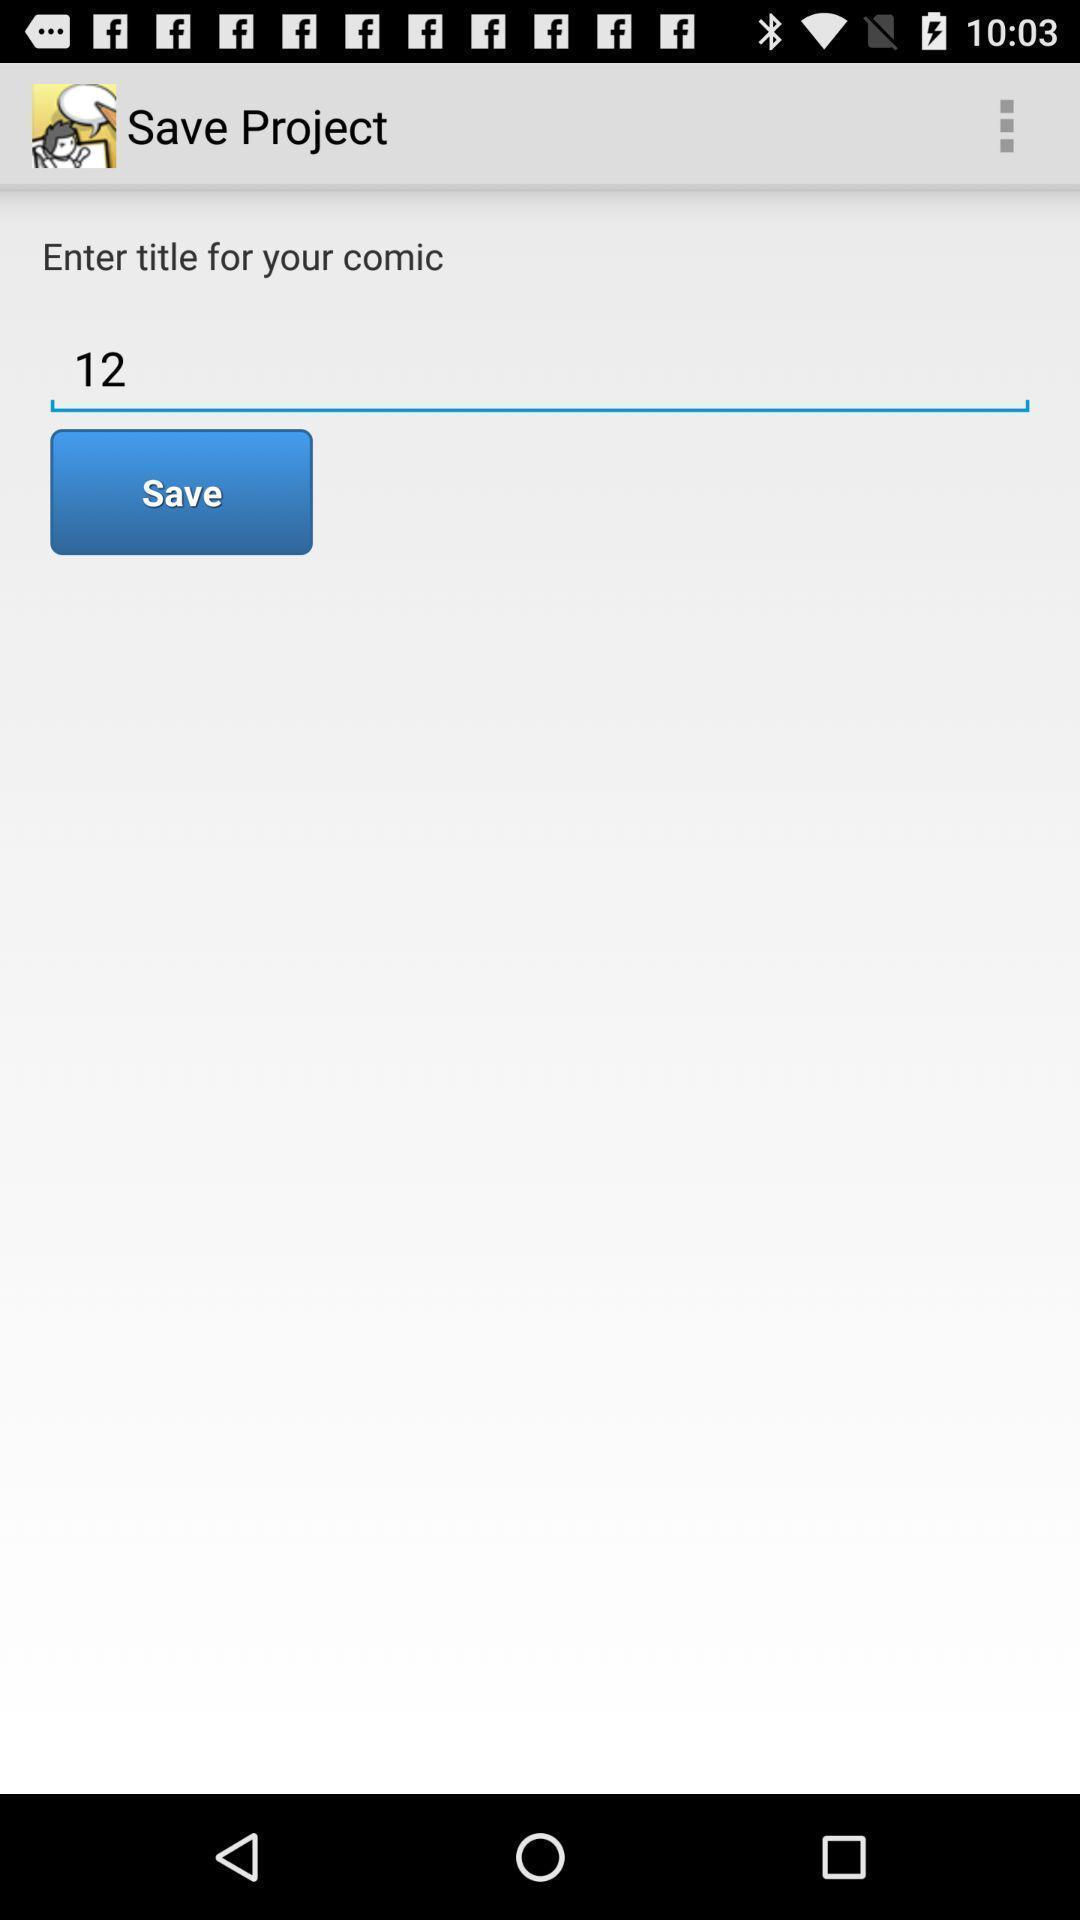Please provide a description for this image. Screen shows save project. 